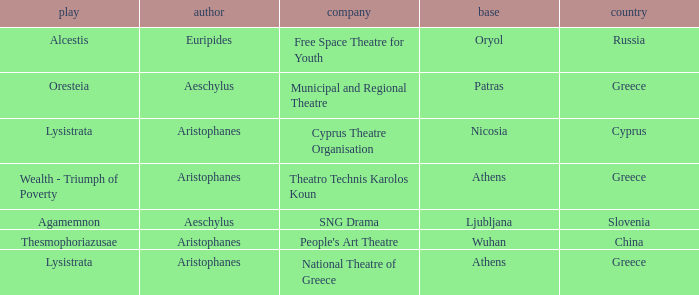What is the country when the base is ljubljana? Slovenia. 